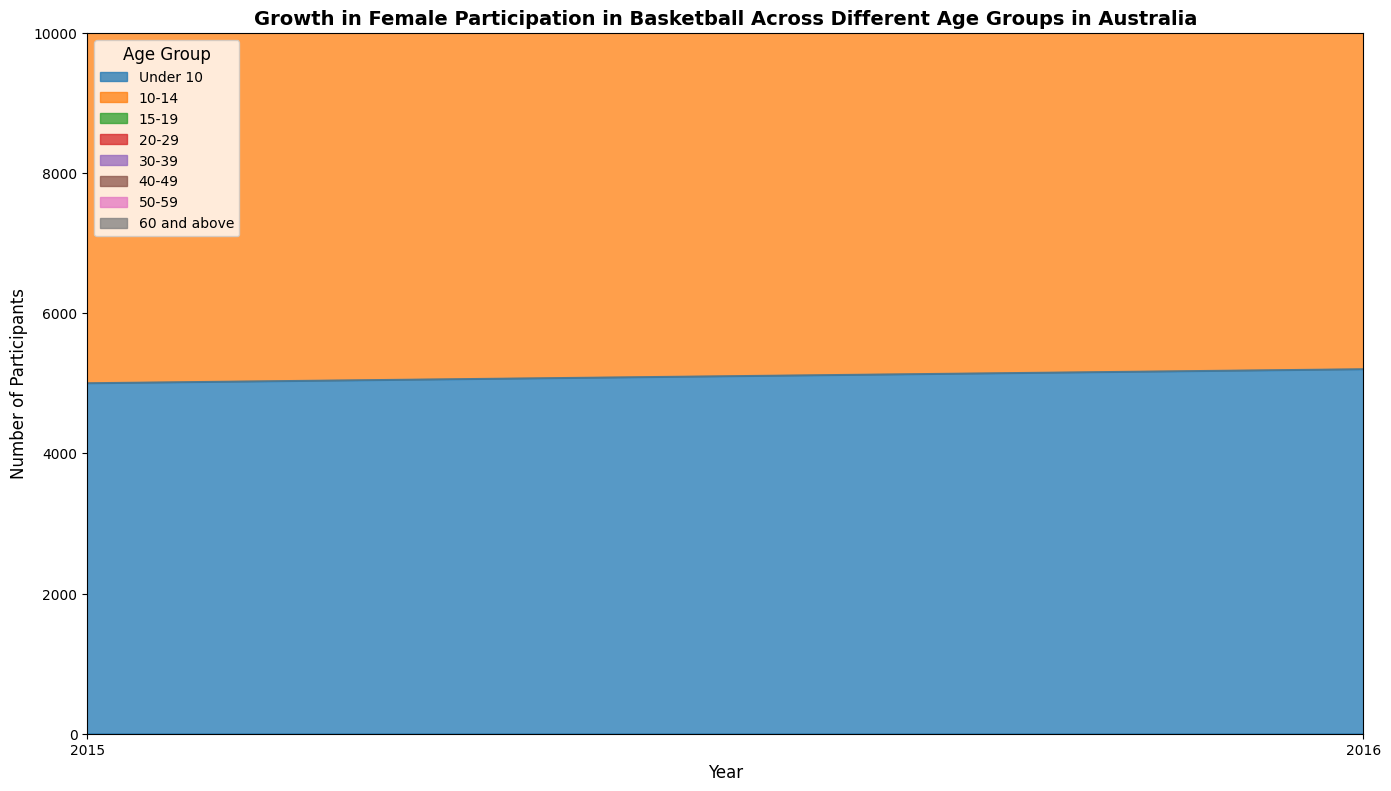What is the general trend of female participation in the 'Under 10' age group over the years? By observing the area for the 'Under 10' age group, which generally increases in height over the years, we can conclude that female participation in this age group has been rising consistently from 2015 to 2022.
Answer: Increasing Which age group shows the most significant increase in participation from 2015 to 2022? To determine this, we look for the age group with the greatest difference in area height between 2015 and 2022. The '10-14' age group shows the most significant increase, starting at 7000 participants in 2015 and reaching 9000 in 2022, an increase of 2000.
Answer: 10-14 In 2022, how does the number of participants in the '15-19' age group compare to the '20-29' age group? Comparing the heights of the areas for these two age groups in 2022, we observe that the '15-19' group has 6000 participants while the '20-29' group has 4200 participants. The '15-19' group has higher participation.
Answer: 15-19 has higher participation What is the average number of participants for the '40-49' age group from 2015 to 2022? To find this, sum the number of participants for the '40-49' age group over the years (1200 + 1300 + 1400 + 1500 + 1600 + 1700 + 1800 + 1900 = 12400) and divide by the number of years (8). The average is 12400 / 8 = 1550.
Answer: 1550 In which year did the '50-59' age group exceed 1000 participants for the first time? By checking the numbers plotted for the '50-59' age group, we see that the number of participants reaches 1000 in the year 2018.
Answer: 2018 Which age group had the smallest number of participants in 2015, and what was that number? By comparing the heights of the areas in 2015, we find that the '60 and above' age group had the smallest number with 400 participants.
Answer: 60 and above, 400 Which year has the most balanced participation across all age groups? A more balanced year will have areas of relatively similar heights. 2022 appears fairly balanced as all areas have grown and no single group dominates the chart.
Answer: 2022 In which year did the '30-39' age group surpass 2500 participants? By checking the plotted values, the '30-39' age group reaches 2600 participants in 2020, the first year it surpasses 2500.
Answer: 2020 